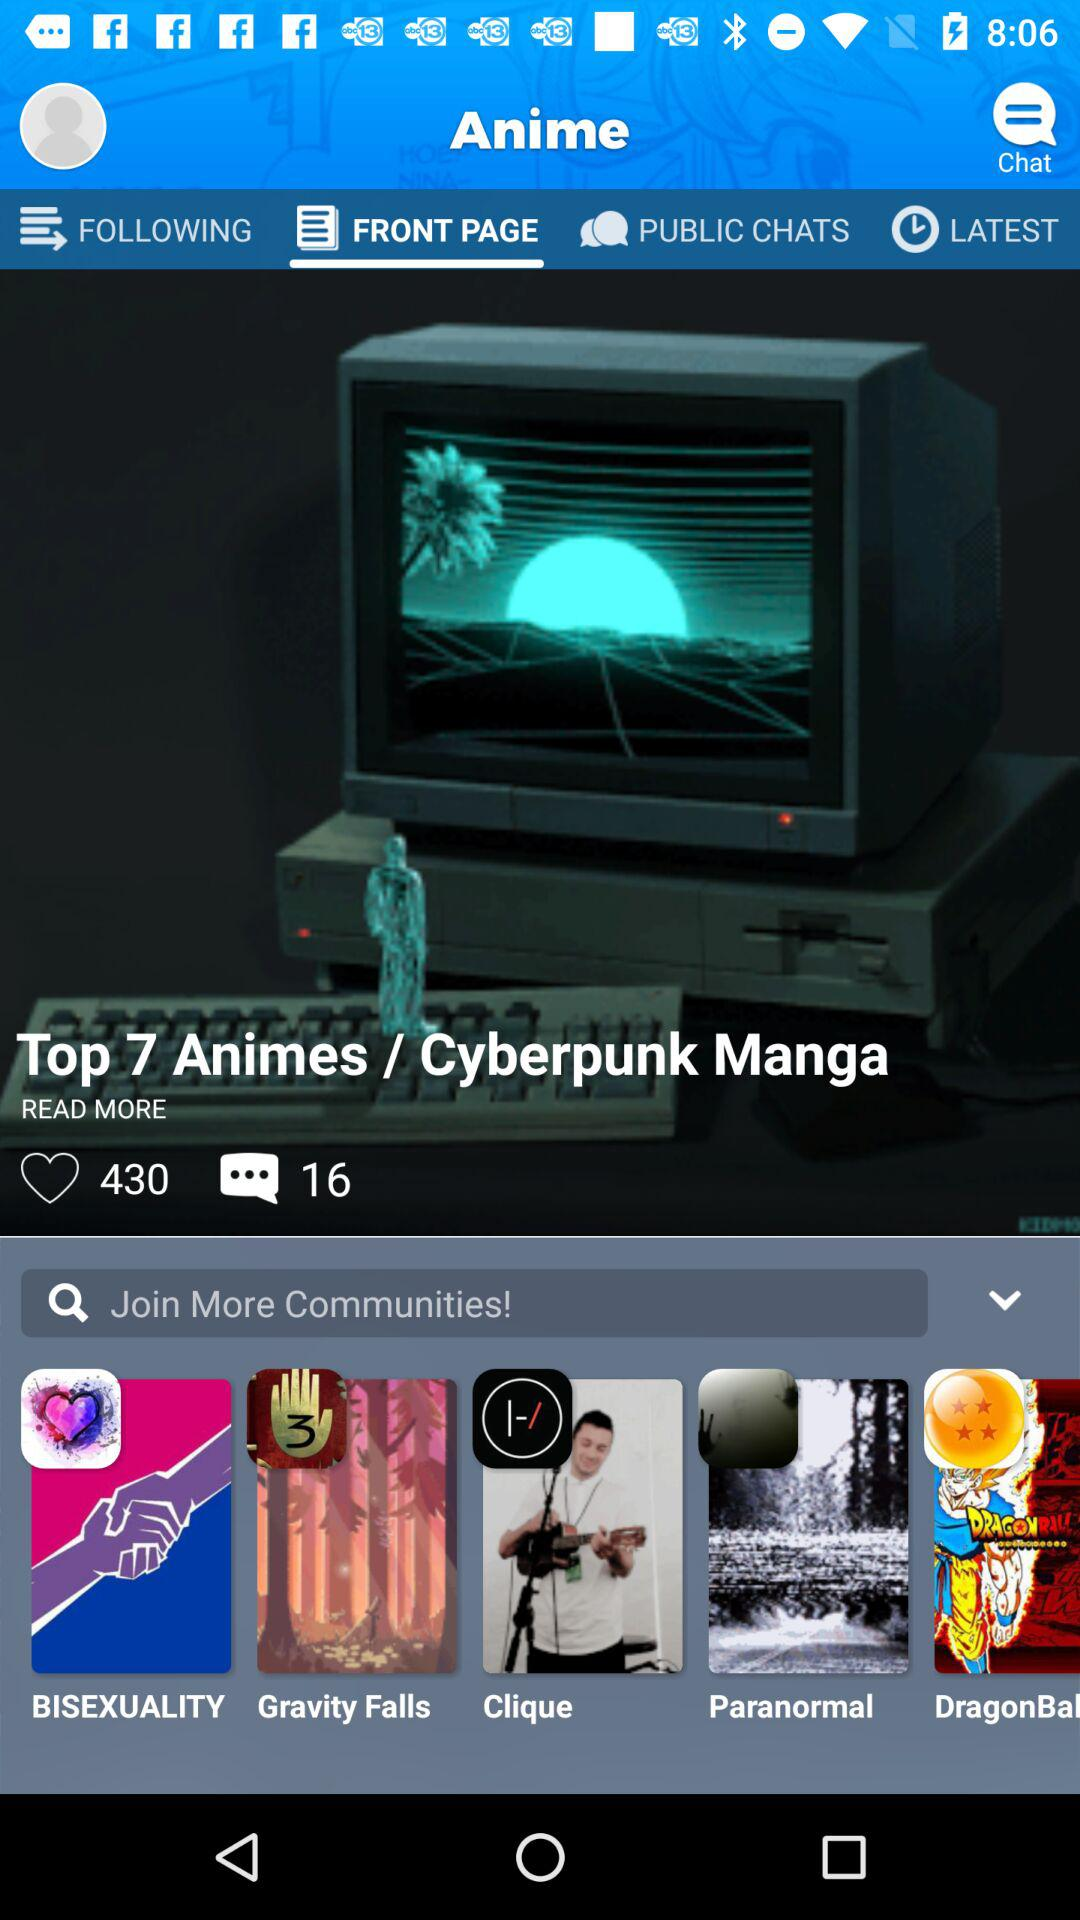What is the total number of likes? The total number of likes is 430. 